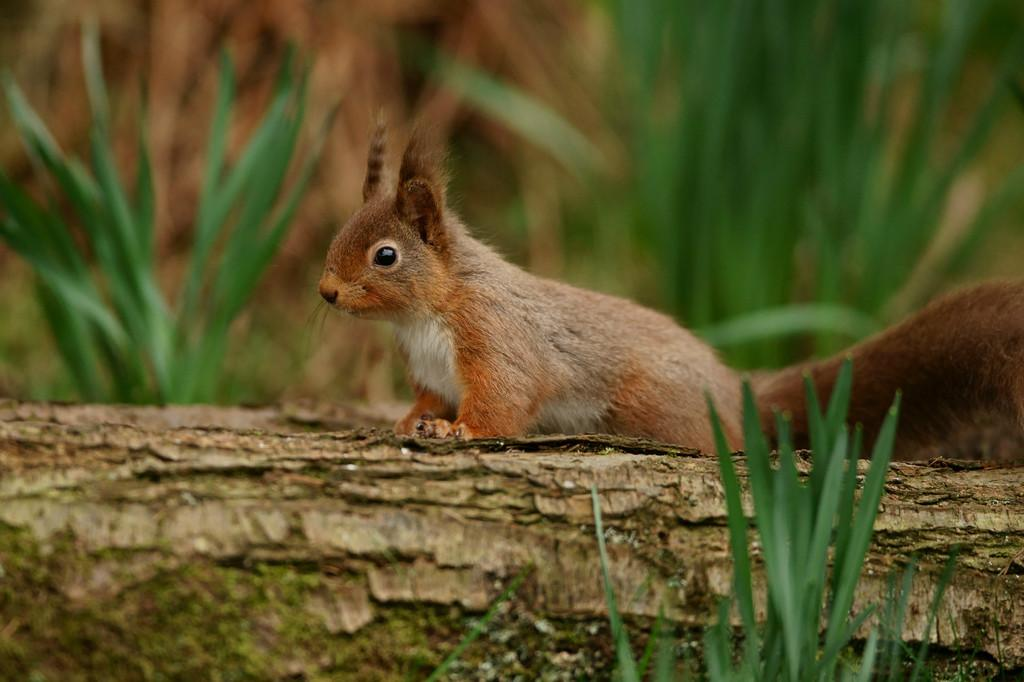What animal can be seen in the image? There is a squirrel in the image. Where is the squirrel located? The squirrel is on a wooden log. What type of vegetation is visible in the image? There is grass visible in the image. How would you describe the background of the image? The background of the image is slightly blurred. What type of unit is being measured by the straw in the image? There is no straw present in the image, so it is not possible to determine what type of unit is being measured. 